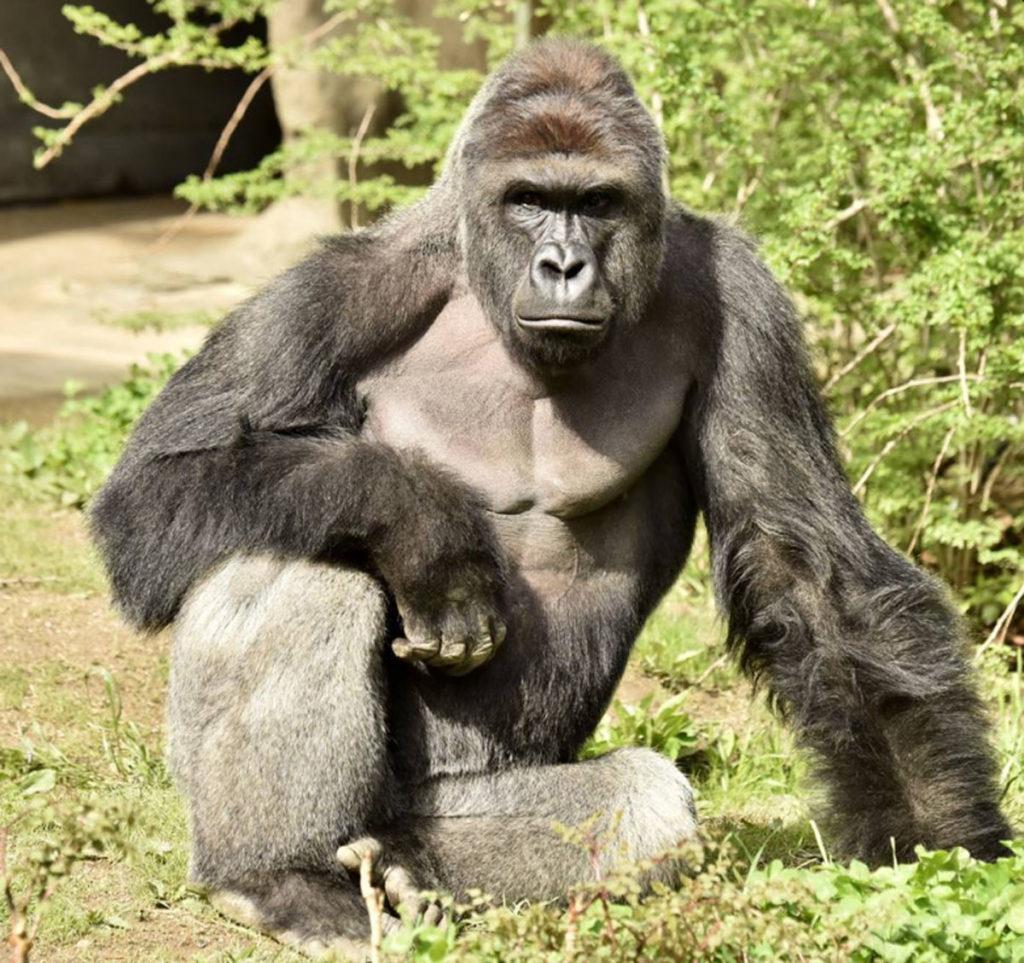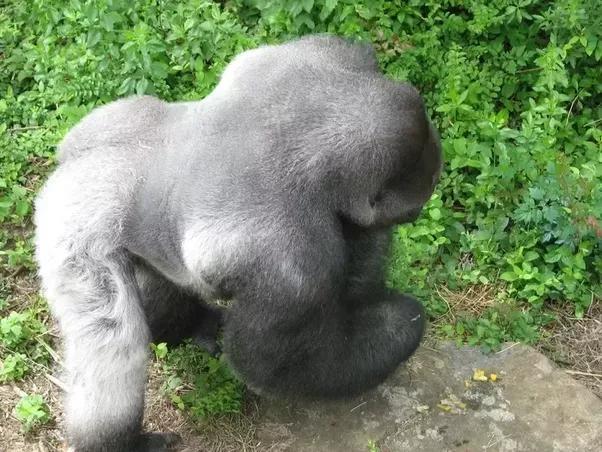The first image is the image on the left, the second image is the image on the right. Evaluate the accuracy of this statement regarding the images: "there's at least one gorilla sitting". Is it true? Answer yes or no. Yes. 